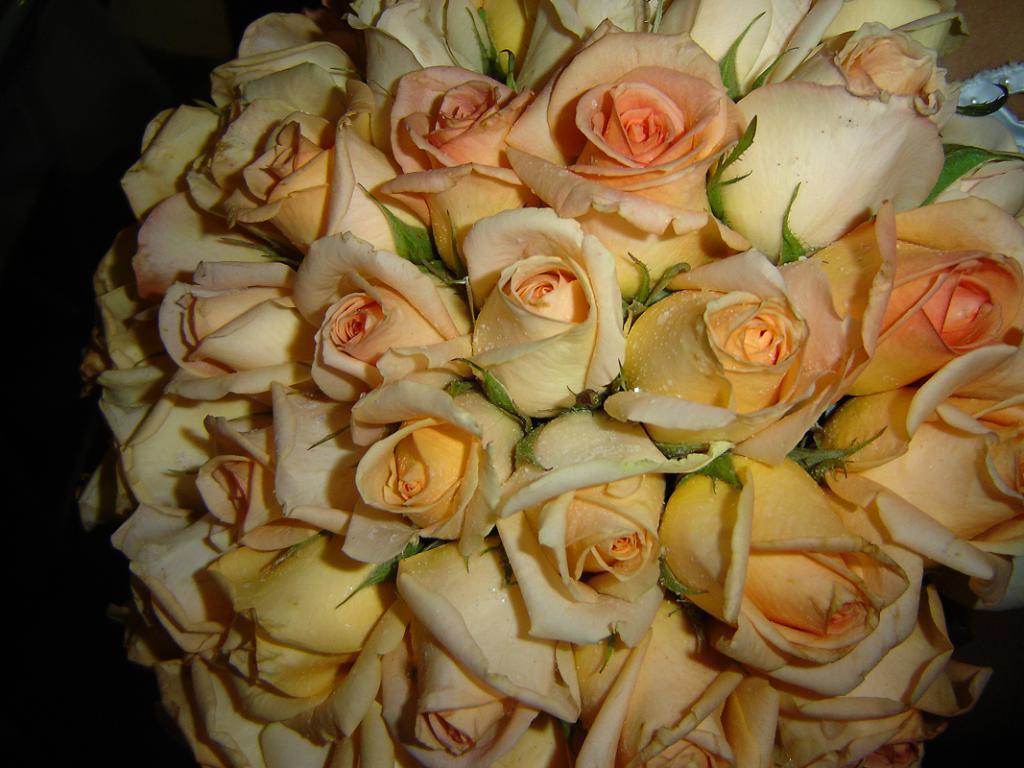How would you summarize this image in a sentence or two? In this image I can see number of rose flowers which are orange, yellow and cream in color and I can see few leaves which are green in color in between them. I can see the black colored background. 